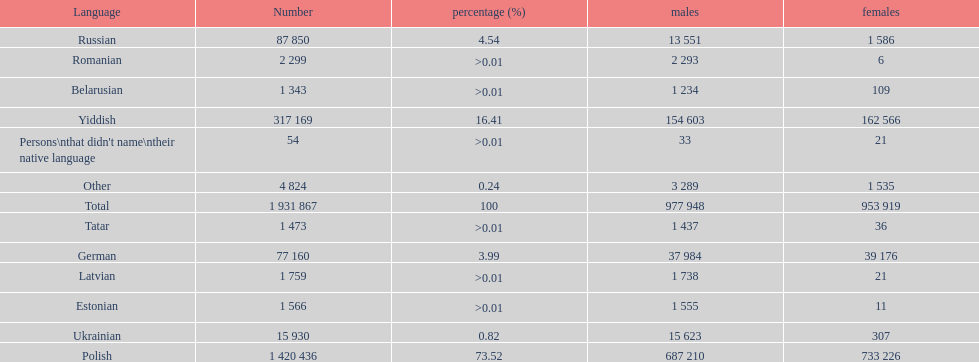What was the next most commonly spoken language in poland after russian? German. 